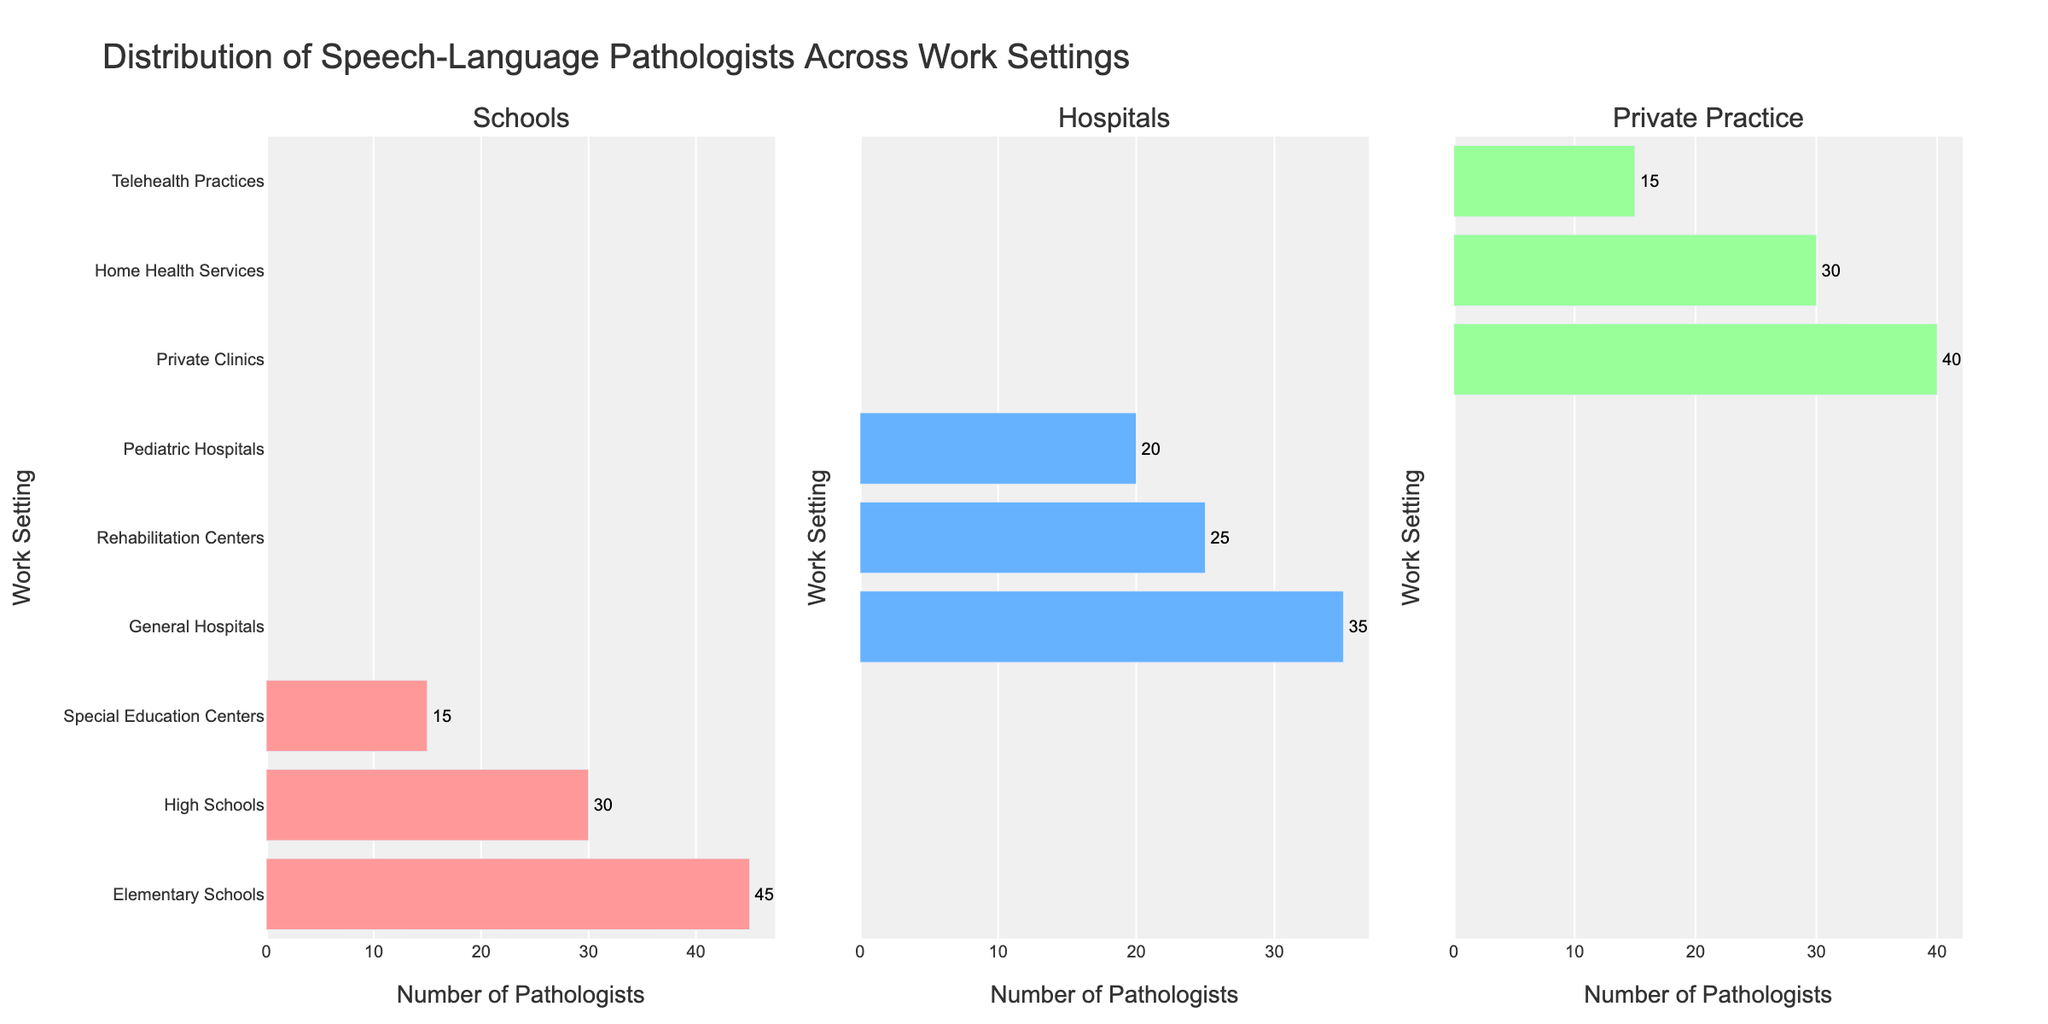what is the title of the figure? The title of the figure is provided at the top of the chart in a large font.
Answer: Distribution of Speech-Language Pathologists Across Work Settings What color bars represent the 'Hospitals' setting? Each setting has distinctively colored bars. The bars for the 'Hospitals' setting are the second group, and they are colored blue.
Answer: Blue Which work setting within schools has the highest number of speech-language pathologists? Look at the three columns representing 'Schools' and identify the bar with the highest value. Count the pathologists for 'Elementary Schools', 'High Schools', and 'Special Education Centers'.
Answer: Elementary Schools How many speech-language pathologists work in pediatric hospitals? Look at the middle subplot for 'Hospitals' settings and find the 'Pediatric Hospitals' bar. This value shows the number of pathologists.
Answer: 20 Do any work settings have exactly 15 speech-language pathologists? Examine the figure to see if any bar reaches 15 in height. In the 'Schools' subplot, 'Special Education Centers' have 15 pathologists.
Answer: Yes, Special Education Centers and Telehealth Practices Which setting has more pathologists: Rehabilitation Centers or Home Health Services? Compare the heights of the corresponding bars in the appropriate subplots. Locate 'Rehabilitation Centers' under 'Hospitals' and 'Home Health Services' under 'Private Practice'.
Answer: Rehabilitation Centers How does the total number of pathologists in private practice compare to schools? Sum up the values in the 'Private Practice' subplot (40+30+15) and in the 'Schools' subplot (45+30+15). Compare the totals: 85 for 'Private Practice' and 90 for 'Schools'.
Answer: Fewer What is the difference in the number of pathologists between General Hospitals and Private Clinics? Subtract the number of pathologists in 'Private Clinics' (40) from those in 'General Hospitals' (35).
Answer: -5 What is the least frequent work setting among all categories? Identify the shortest bars across all three subplots. 'Telehealth Practices' has the fewest pathologists among all categories.
Answer: Telehealth Practices 